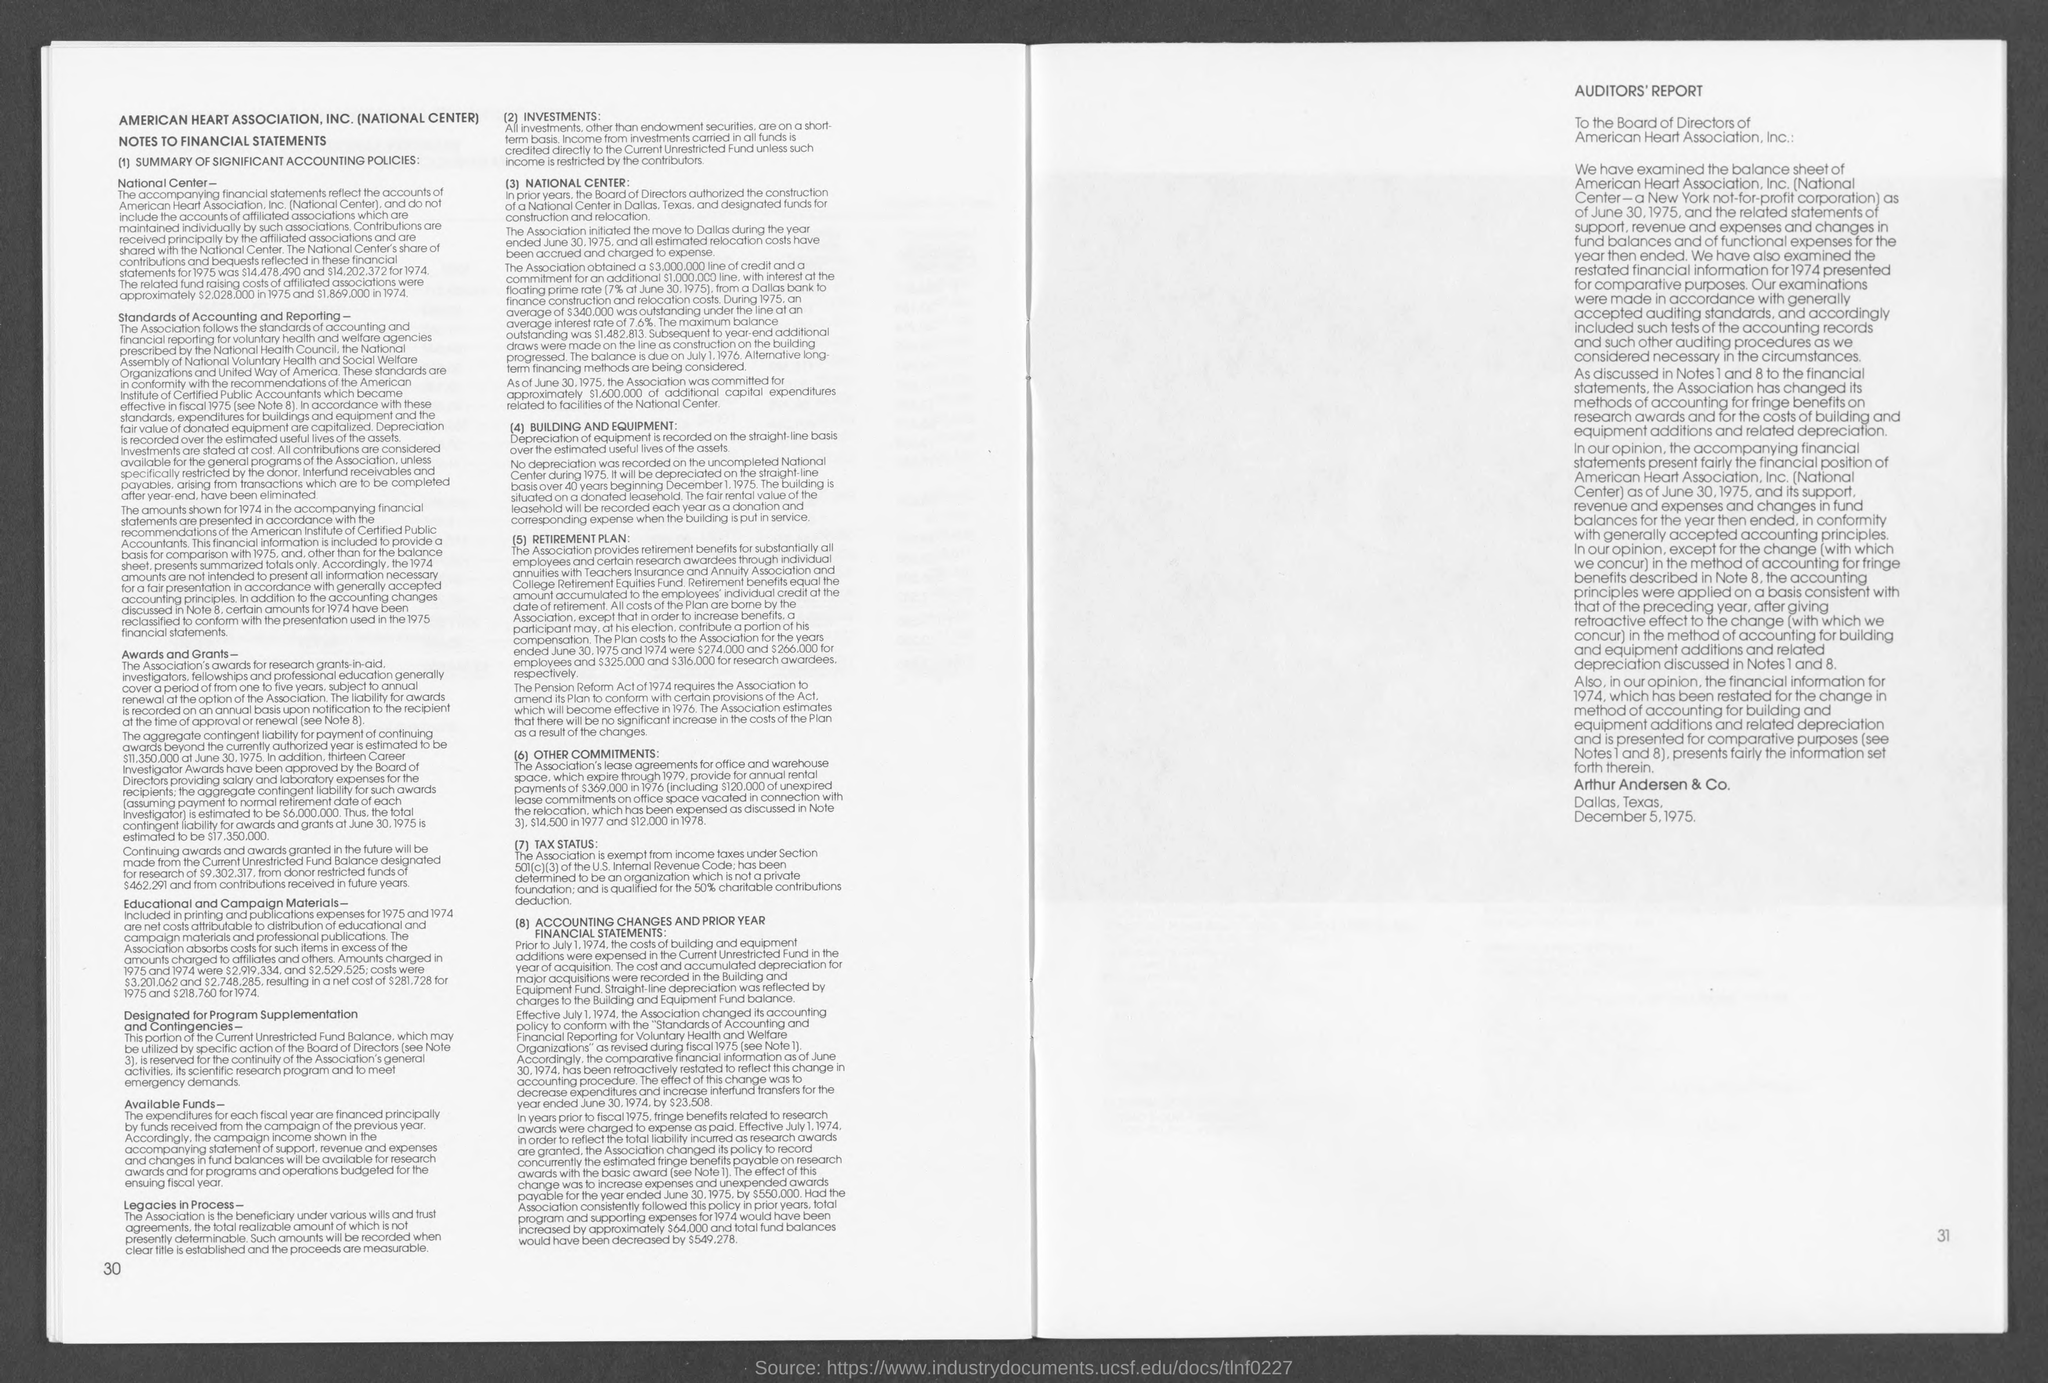When was pension reform act formed?
Your answer should be compact. 1974. What are the investments based on?
Give a very brief answer. Short-term. 